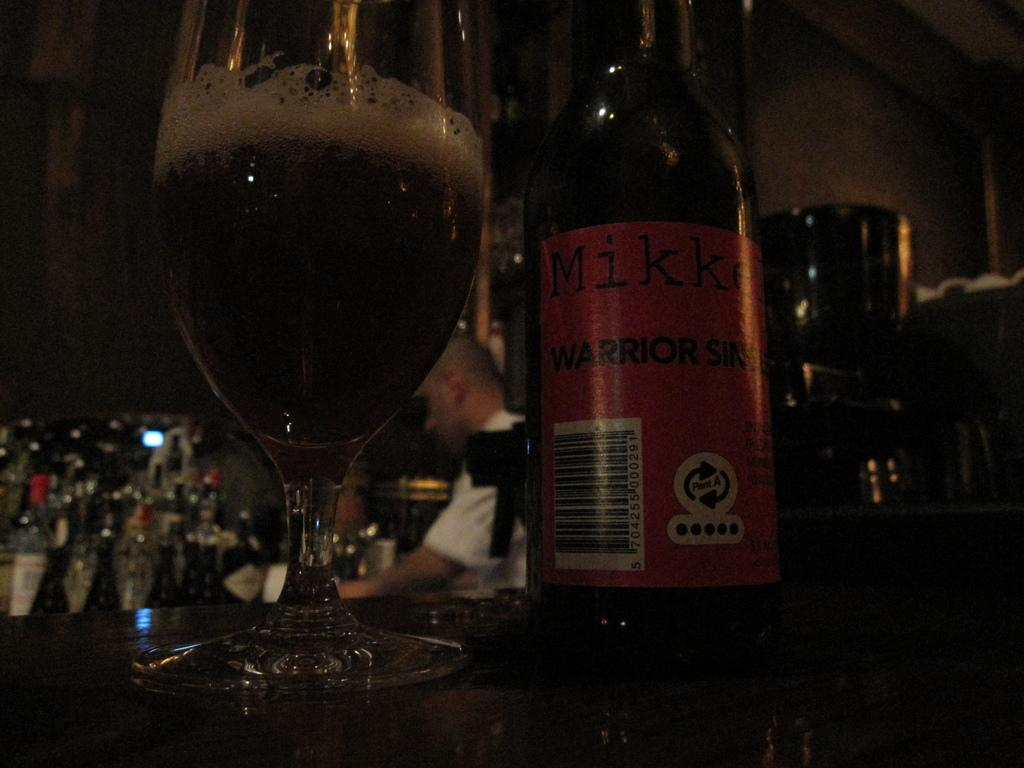What type of containers are present in the image? There are bottles in the image. What is inside one of the containers? There is a glass with wine in the image. Can you describe the person in the image? There is a person standing in the image. What type of question is being asked by the person in the image? There is no indication in the image that a question is being asked, as the person's actions or expressions are not visible. 